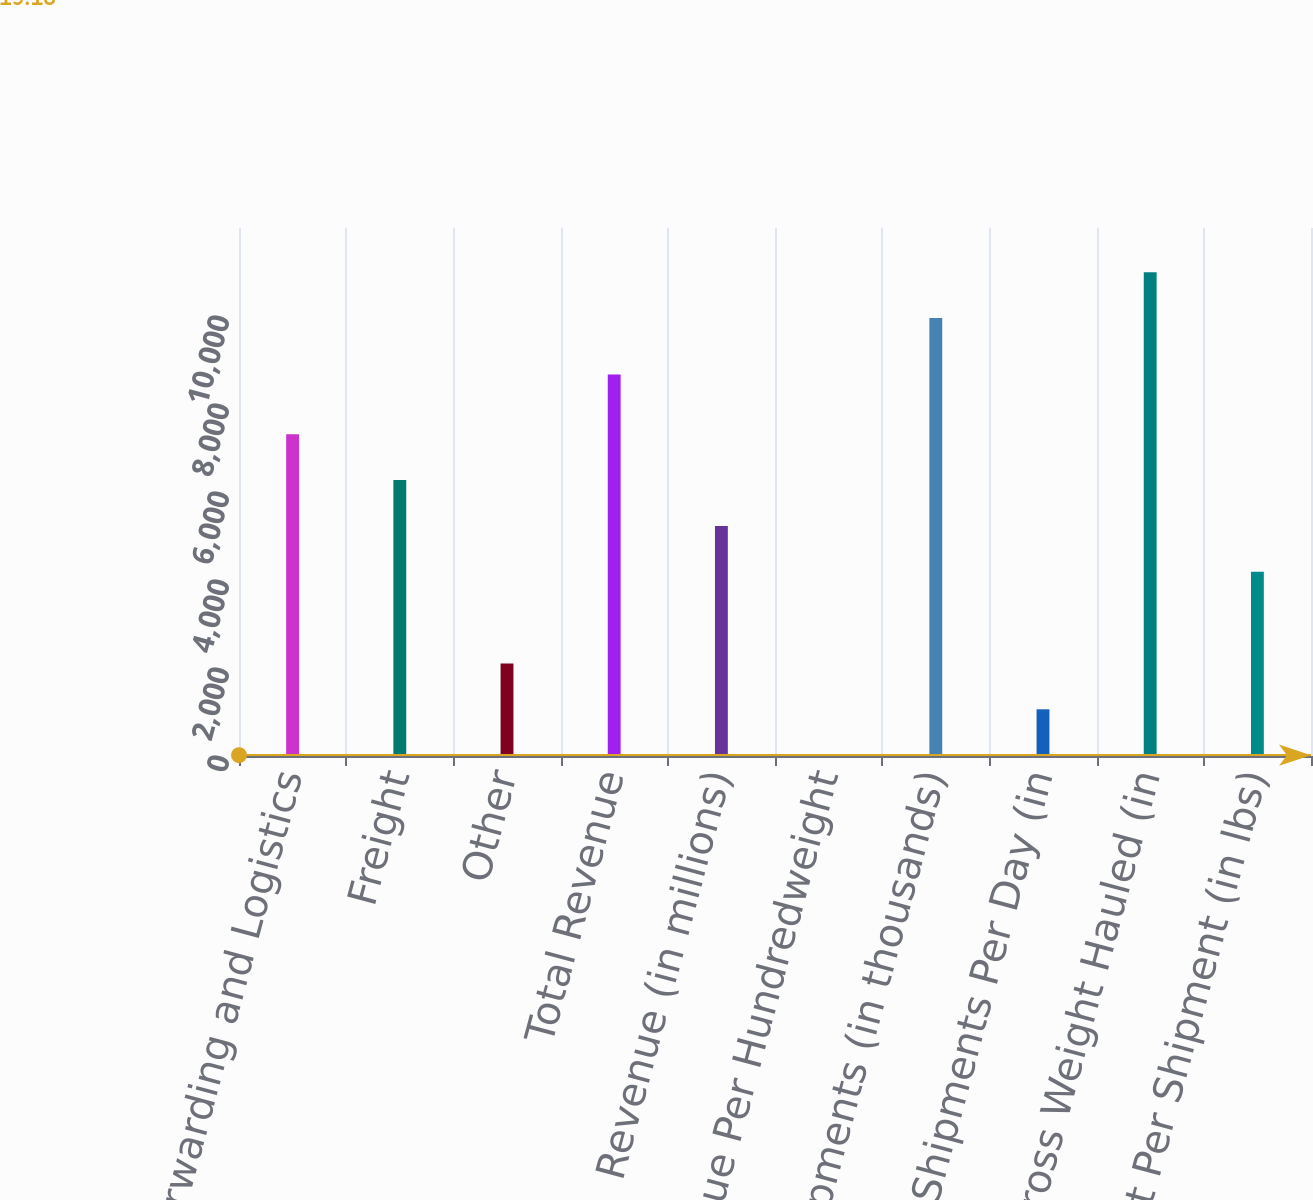Convert chart. <chart><loc_0><loc_0><loc_500><loc_500><bar_chart><fcel>Forwarding and Logistics<fcel>Freight<fcel>Other<fcel>Total Revenue<fcel>Revenue (in millions)<fcel>Revenue Per Hundredweight<fcel>Shipments (in thousands)<fcel>Shipments Per Day (in<fcel>Gross Weight Hauled (in<fcel>Weight Per Shipment (in lbs)<nl><fcel>7313.74<fcel>6271.66<fcel>2103.34<fcel>8670<fcel>5229.58<fcel>19.18<fcel>9952<fcel>1061.26<fcel>10994.1<fcel>4187.5<nl></chart> 